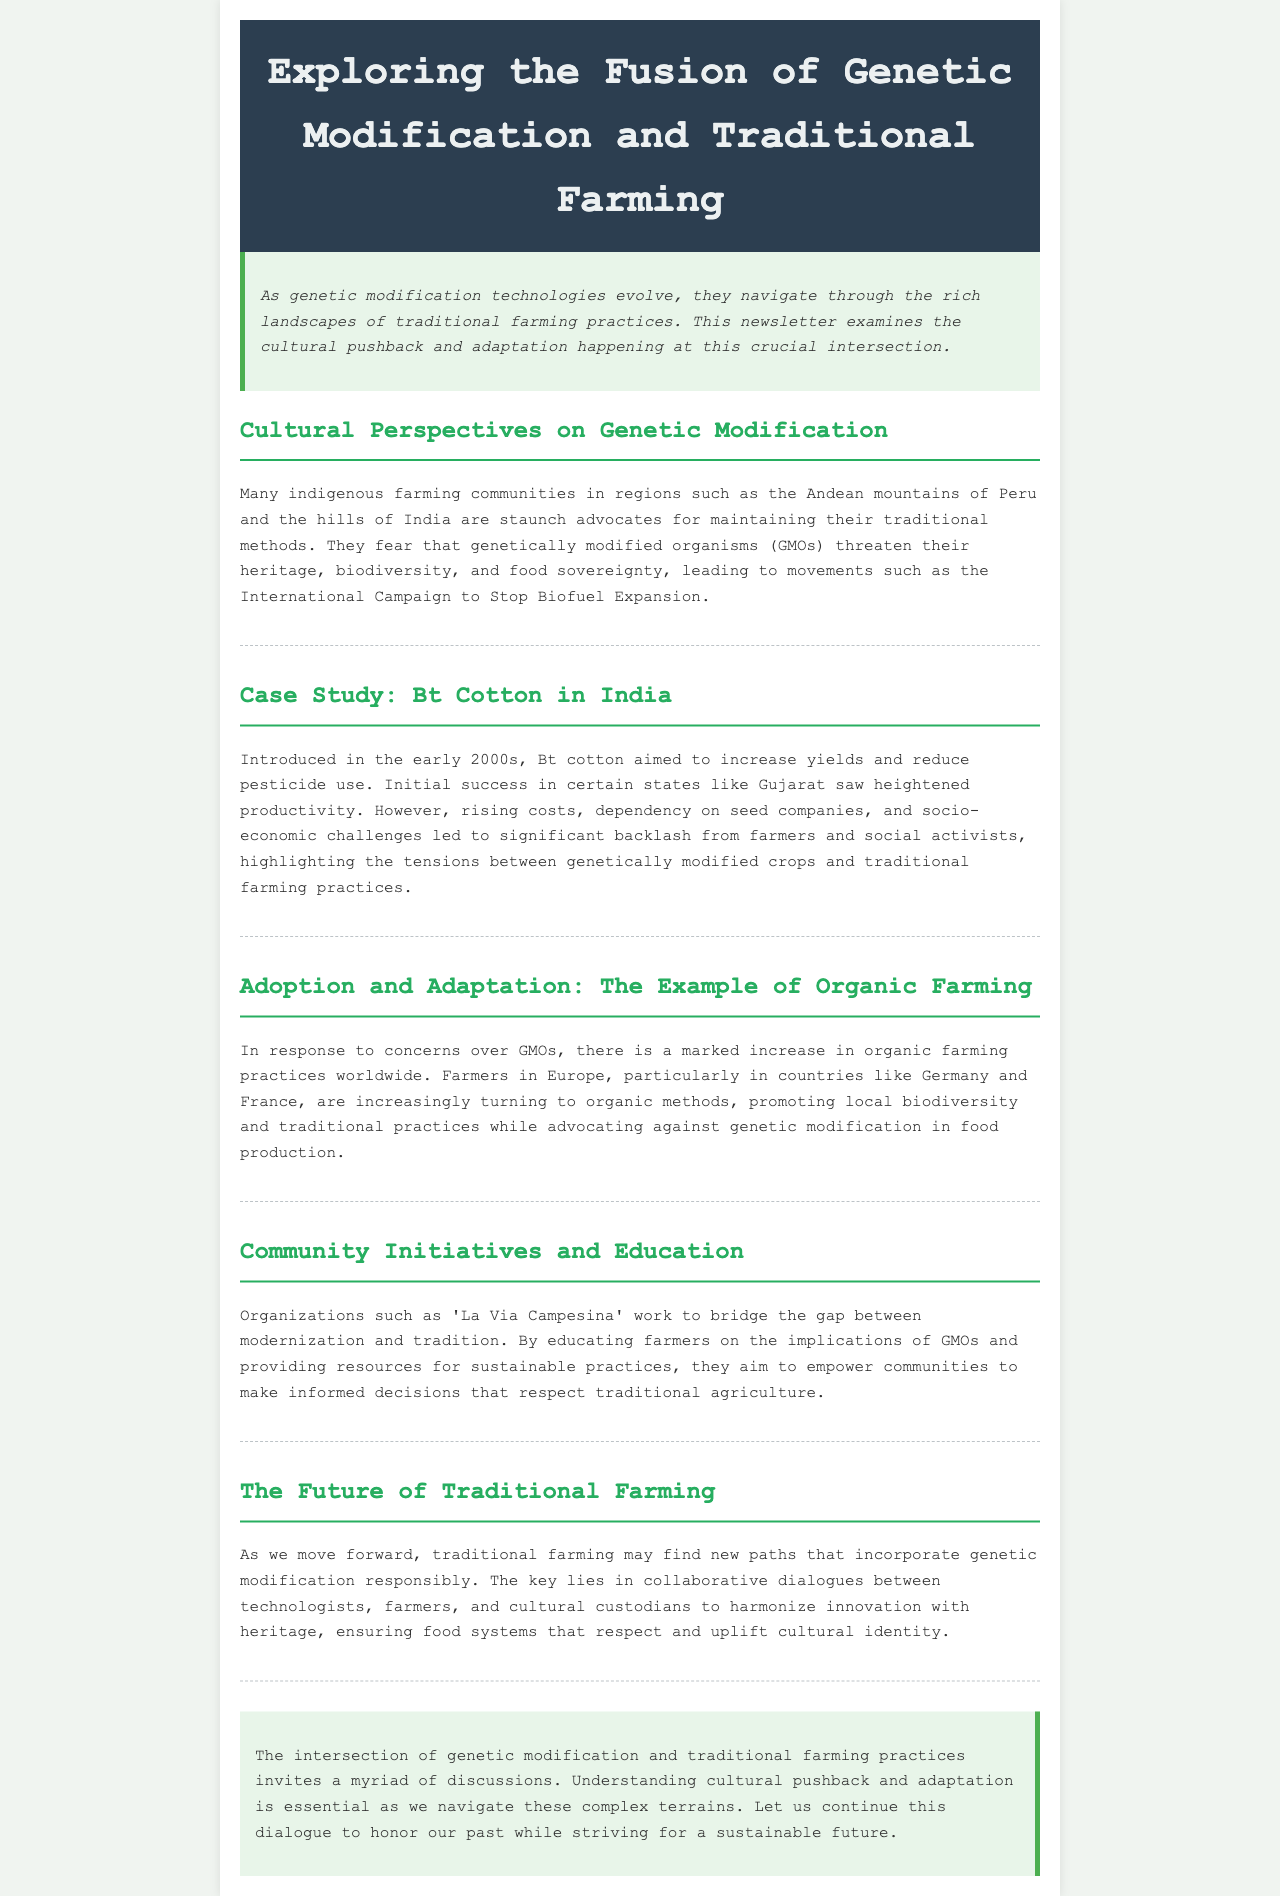What is the focus of the newsletter? The newsletter focuses on the cultural pushback and adaptation at the intersection of genetic modification and traditional farming practices.
Answer: cultural pushback and adaptation Which communities are mentioned as advocates for traditional methods? The document mentions indigenous farming communities in the Andean mountains of Peru and the hills of India.
Answer: indigenous farming communities When was Bt cotton introduced in India? Bt cotton was introduced in the early 2000s according to the case study mentioned.
Answer: early 2000s What is increasing worldwide in response to concerns over GMOs? The newsletter notes a marked increase in organic farming practices worldwide.
Answer: organic farming practices What organization works to bridge the gap between modernization and tradition? 'La Via Campesina' is the organization mentioned that works to bridge this gap.
Answer: La Via Campesina What socio-economic challenges arose with Bt cotton? The document notes rising costs and dependency on seed companies as socio-economic challenges.
Answer: rising costs and dependency What do farmers in Europe advocate against? According to the newsletter, farmers in Europe are advocating against genetic modification in food production.
Answer: genetic modification What key element is essential for the future of traditional farming? The document emphasizes that collaborative dialogues between technologists, farmers, and cultural custodians are essential.
Answer: collaborative dialogues 